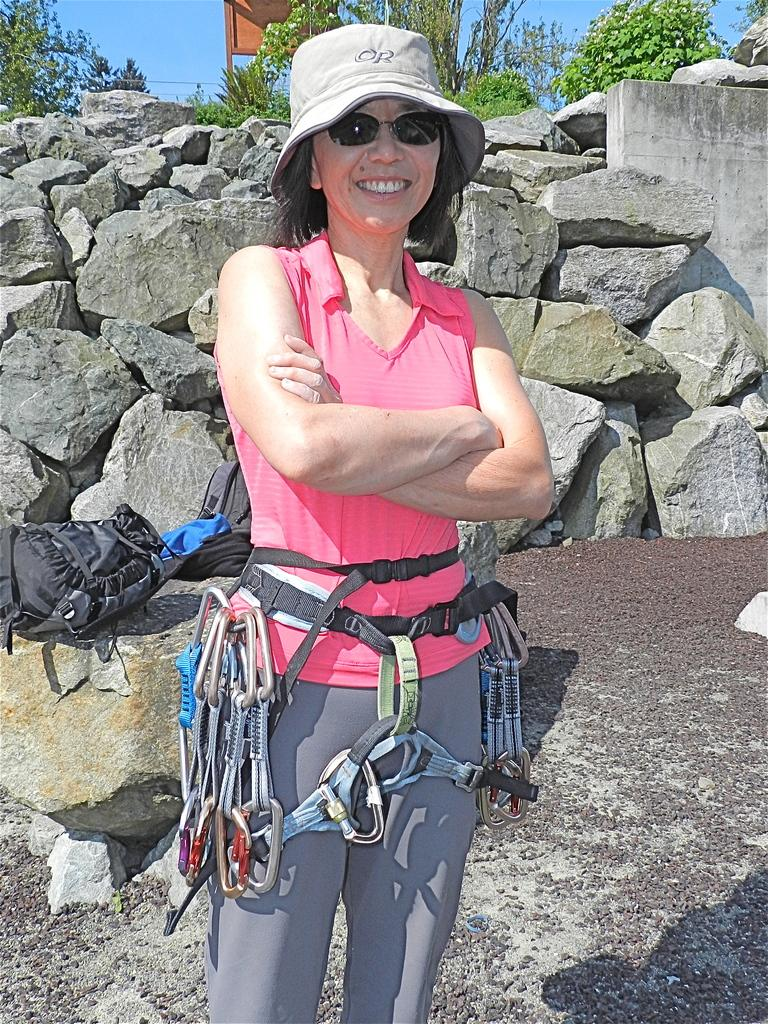What is the main subject of the image? There is a lady standing in the center of the image. What is the lady wearing on her head? The lady is wearing a cap. What can be seen in the background of the image? There are bags, rocks, trees, and the sky visible in the background of the image. What color is the paint on the drawer in the image? There is no drawer or paint present in the image. How does the lady push the rocks in the image? The lady is not pushing the rocks in the image; she is simply standing in the center. 